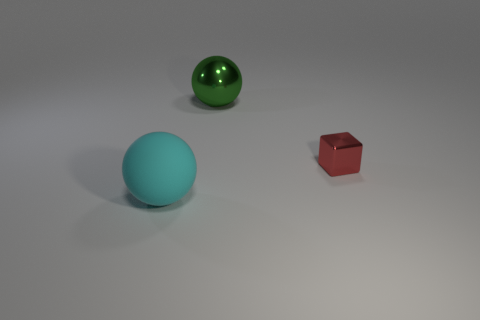Subtract all green balls. How many balls are left? 1 Add 2 purple rubber cylinders. How many objects exist? 5 Subtract all blocks. How many objects are left? 2 Subtract all big cyan shiny spheres. Subtract all small things. How many objects are left? 2 Add 1 tiny red things. How many tiny red things are left? 2 Add 1 large cyan matte things. How many large cyan matte things exist? 2 Subtract 0 blue blocks. How many objects are left? 3 Subtract all brown cubes. Subtract all cyan cylinders. How many cubes are left? 1 Subtract all yellow cylinders. How many cyan spheres are left? 1 